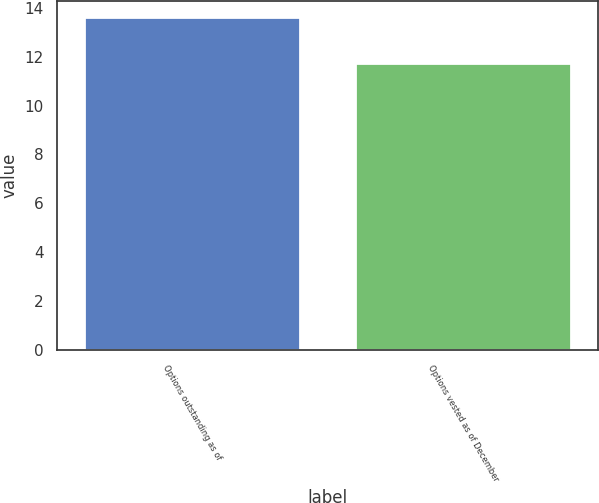Convert chart to OTSL. <chart><loc_0><loc_0><loc_500><loc_500><bar_chart><fcel>Options outstanding as of<fcel>Options vested as of December<nl><fcel>13.61<fcel>11.73<nl></chart> 